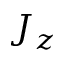<formula> <loc_0><loc_0><loc_500><loc_500>J _ { z }</formula> 